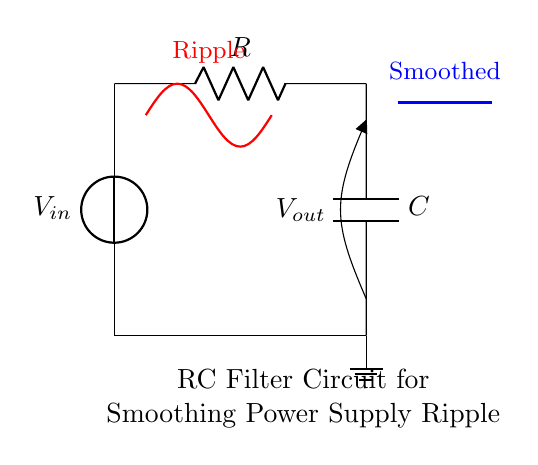What are the components in this circuit? The components in this RC filter circuit include a voltage source labeled V_in, a resistor labeled R, and a capacitor labeled C. These are clearly represented in the diagram with their respective symbols.
Answer: Voltage source, resistor, capacitor What is the output voltage in the circuit? The output voltage V_out is measured across the capacitor C. Since it is marked as an output in the diagram, it indicates the point where the smoothed voltage is taken from.
Answer: V_out What is the purpose of the capacitor in this circuit? The capacitor serves to smooth the ripple voltage produced by the power supply. It charges and discharges to filter out the high-frequency fluctuations, providing a steadier output voltage.
Answer: To smooth ripple How does the resistor affect the charging time of the capacitor? The resistor R controls the time constant of the RC circuit, which affects the rate at which the capacitor charges and discharges. The time constant, denoted as tau (τ), is equal to R times C, influencing how quickly the capacitor can respond to changes in the input voltage.
Answer: By controlling time constant What does the red line in the diagram represent? The red line represents the ripple voltage present at the output before filtering. It indicates the high-frequency fluctuations that the capacitor reduces over time to produce a smoother output.
Answer: Ripple voltage What happens if the resistance is increased in this circuit? Increasing the resistance will increase the time constant of the circuit, making the capacitor charge and discharge more slowly. This may lead to a less responsive filter, which could either stabilize the output more or allow more ripple to pass through, depending on the frequency of the input ripple.
Answer: Slower response How does the capacitor behavior change with frequency in this circuit? The behavior of the capacitor is frequency-dependent; higher frequencies see a greater reactance which prevents the capacitor from charging effectively, while at lower frequencies, the reactance is lower allowing the capacitor to charge more efficiently and smooth the output.
Answer: Reactance varies with frequency 